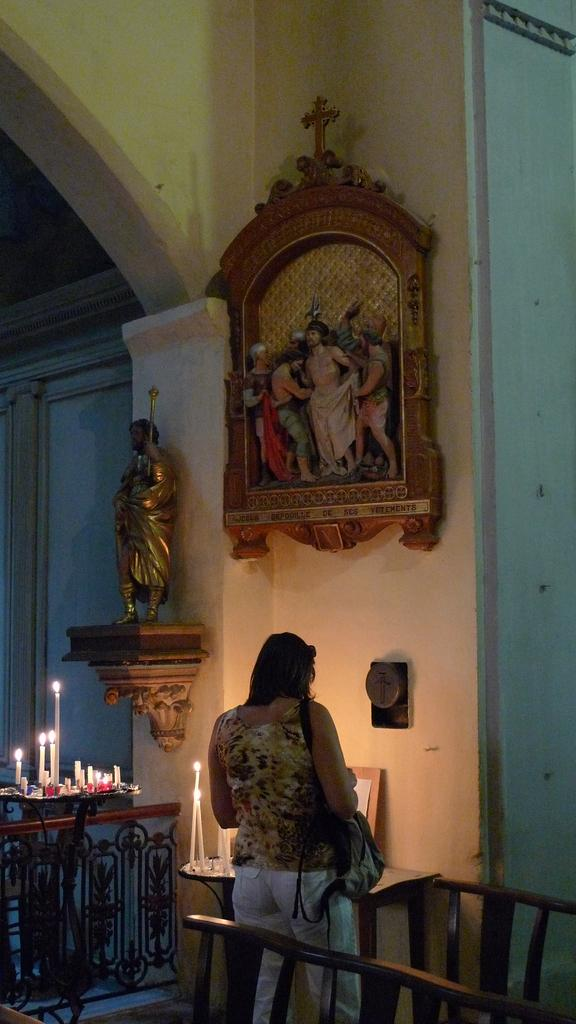What is the main subject of the image? There is a woman in the image. What is the woman doing in the image? The woman is standing in the image. What object is the woman holding? The woman is holding a handbag. What can be seen on the table in the image? There are candles on the table in the image. What type of decoration is present on the wall? There are sculptures on the wall in the image. What color is the sweater the woman is wearing in the image? The image does not show the woman wearing a sweater, so we cannot determine its color. How much pain is the woman experiencing in the image? There is no indication of pain in the image, so we cannot determine the level of pain the woman might be experiencing. 